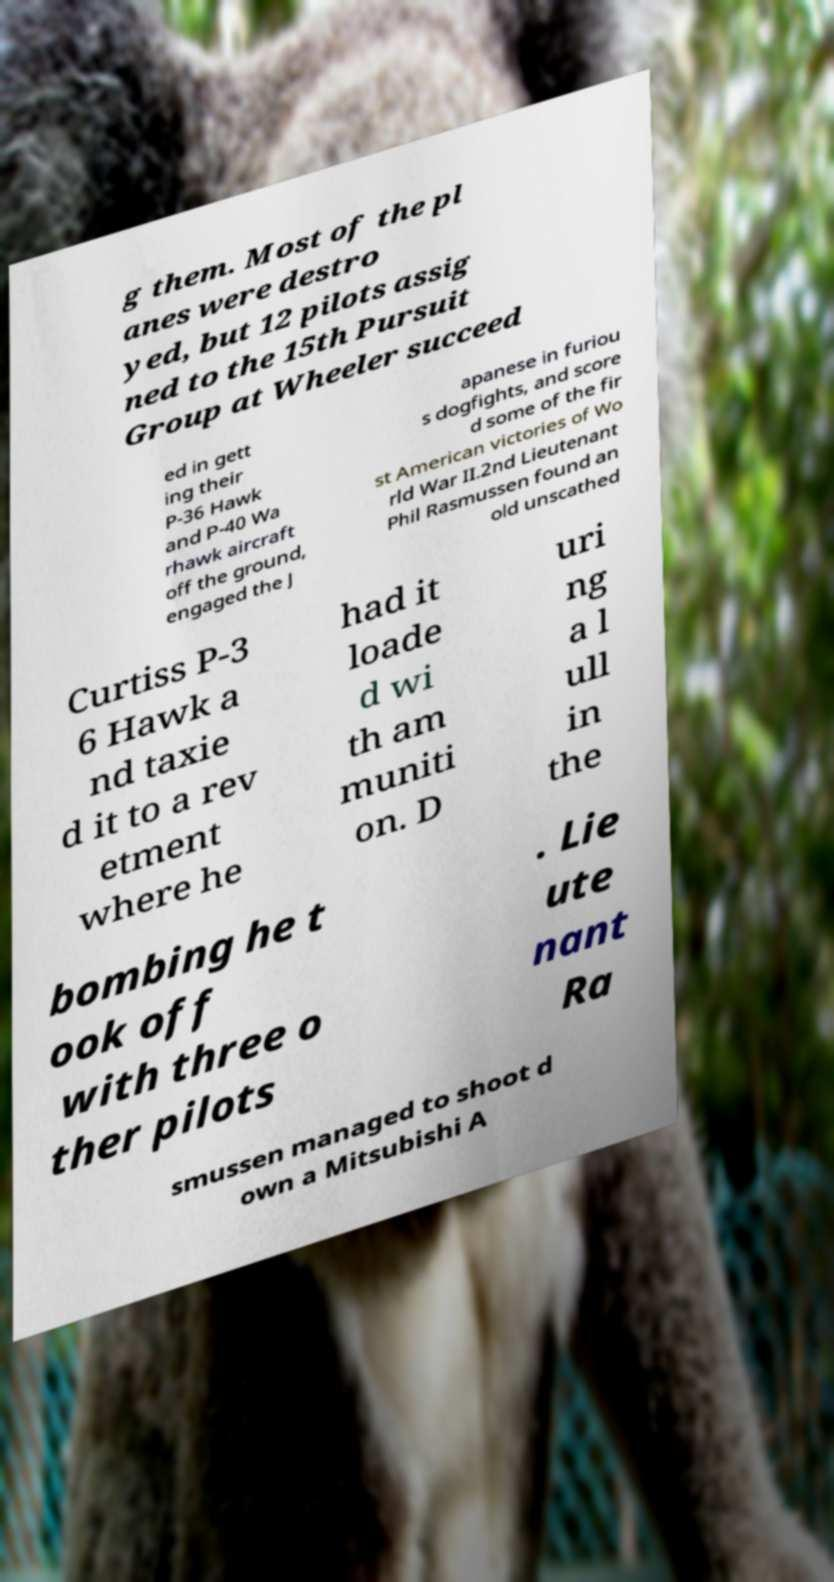Please identify and transcribe the text found in this image. g them. Most of the pl anes were destro yed, but 12 pilots assig ned to the 15th Pursuit Group at Wheeler succeed ed in gett ing their P-36 Hawk and P-40 Wa rhawk aircraft off the ground, engaged the J apanese in furiou s dogfights, and score d some of the fir st American victories of Wo rld War II.2nd Lieutenant Phil Rasmussen found an old unscathed Curtiss P-3 6 Hawk a nd taxie d it to a rev etment where he had it loade d wi th am muniti on. D uri ng a l ull in the bombing he t ook off with three o ther pilots . Lie ute nant Ra smussen managed to shoot d own a Mitsubishi A 